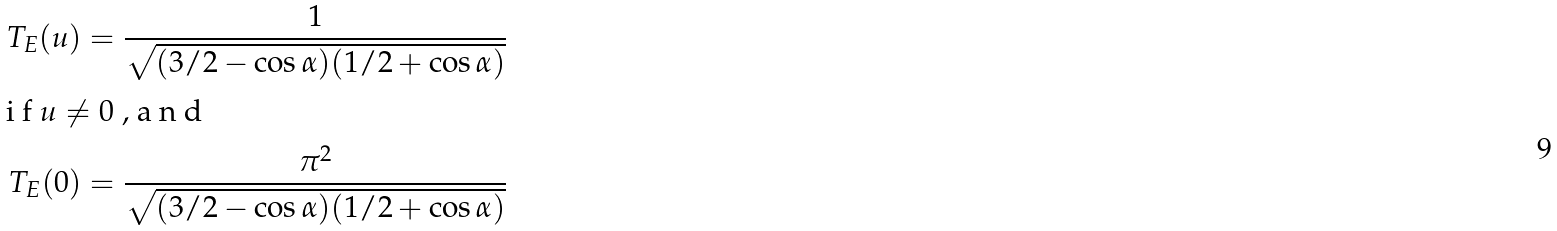<formula> <loc_0><loc_0><loc_500><loc_500>T _ { E } ( u ) & = \frac { 1 } { \sqrt { ( 3 / 2 - \cos \alpha ) ( 1 / 2 + \cos \alpha ) } } \\ \intertext { i f $ u \ne 0 $ , a n d } T _ { E } ( 0 ) & = \frac { \pi ^ { 2 } } { \sqrt { ( 3 / 2 - \cos \alpha ) ( 1 / 2 + \cos \alpha ) } }</formula> 